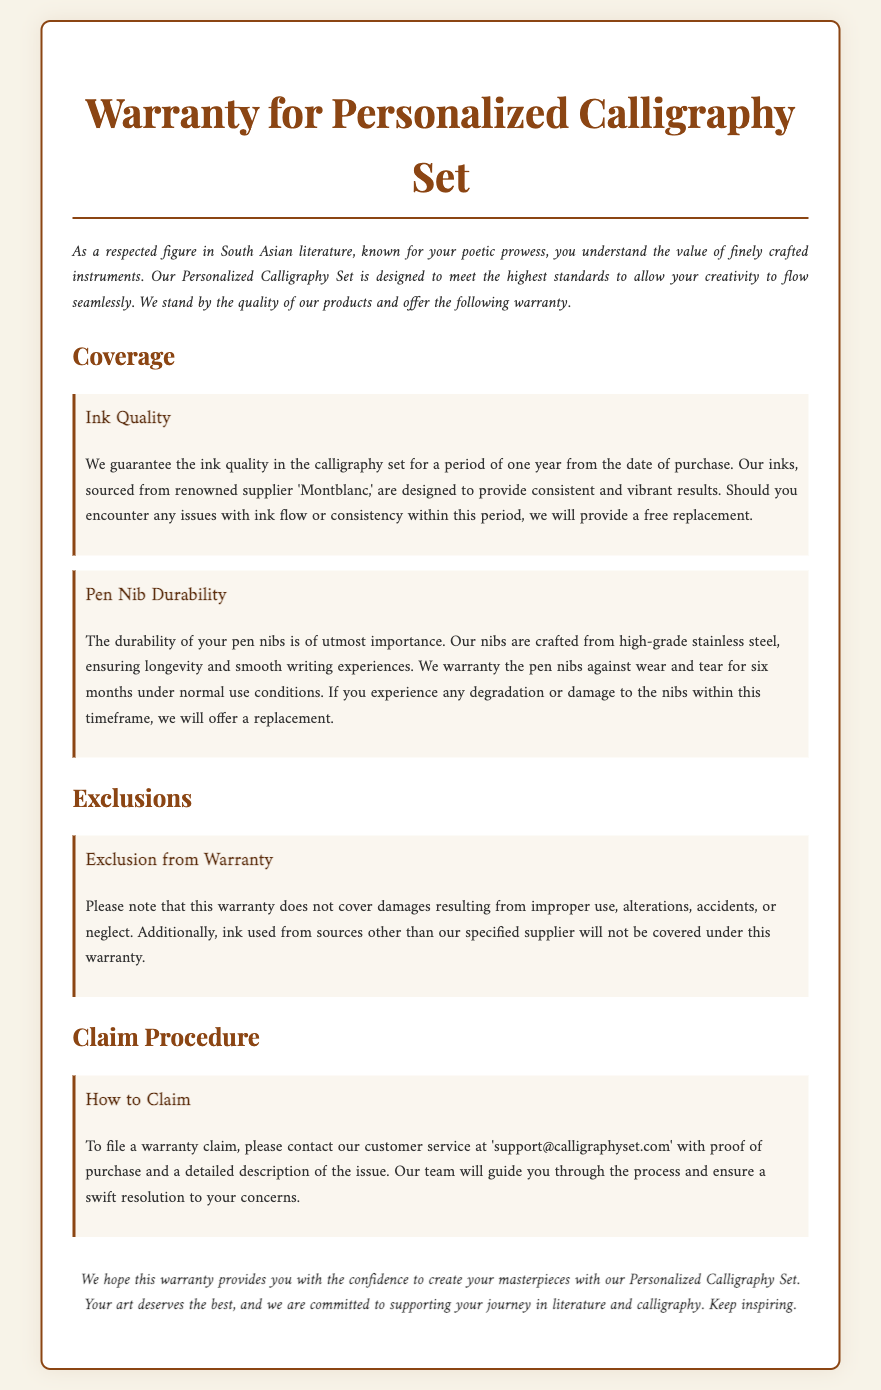What is guaranteed for one year? The document states that the ink quality in the calligraphy set is guaranteed for a period of one year from the date of purchase.
Answer: Ink quality What is the warranty period for pen nib durability? The warranty for pen nib durability is specified as six months under normal use conditions.
Answer: Six months Who is the ink supplier mentioned? The ink used in the calligraphy set is sourced from the renowned supplier 'Montblanc.'
Answer: Montblanc What is excluded from the warranty? The warranty does not cover damages resulting from improper use, alterations, accidents, or neglect.
Answer: Improper use How can you file a warranty claim? To file a warranty claim, you need to contact customer service with proof of purchase and a detailed description of the issue.
Answer: Email customer service What material are the pen nibs made of? The document mentions that the pen nibs are crafted from high-grade stainless steel.
Answer: Stainless steel What is the document type? The document is categorized as a warranty for a personalized calligraphy set.
Answer: Warranty How long is the ink guaranteed for? The ink is guaranteed for a period of one year from the date of purchase.
Answer: One year 